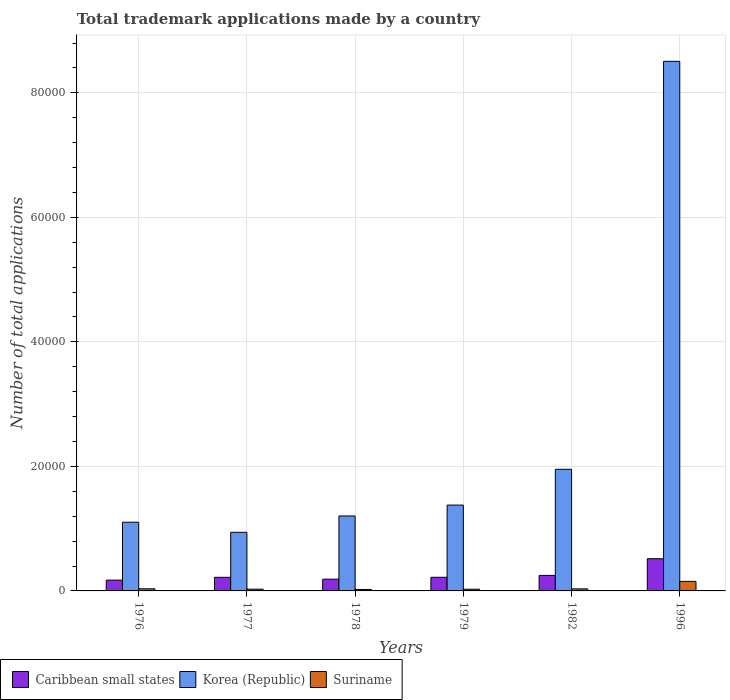How many different coloured bars are there?
Offer a terse response. 3. What is the label of the 4th group of bars from the left?
Your answer should be compact. 1979. What is the number of applications made by in Caribbean small states in 1976?
Your answer should be compact. 1735. Across all years, what is the maximum number of applications made by in Korea (Republic)?
Provide a succinct answer. 8.51e+04. Across all years, what is the minimum number of applications made by in Suriname?
Your response must be concise. 236. In which year was the number of applications made by in Korea (Republic) minimum?
Offer a terse response. 1977. What is the total number of applications made by in Caribbean small states in the graph?
Provide a succinct answer. 1.57e+04. What is the difference between the number of applications made by in Korea (Republic) in 1976 and that in 1982?
Offer a terse response. -8500. What is the difference between the number of applications made by in Korea (Republic) in 1982 and the number of applications made by in Caribbean small states in 1978?
Give a very brief answer. 1.77e+04. What is the average number of applications made by in Caribbean small states per year?
Provide a short and direct response. 2610.17. In the year 1978, what is the difference between the number of applications made by in Suriname and number of applications made by in Korea (Republic)?
Your answer should be very brief. -1.18e+04. What is the ratio of the number of applications made by in Caribbean small states in 1976 to that in 1979?
Provide a succinct answer. 0.79. Is the number of applications made by in Suriname in 1977 less than that in 1978?
Provide a succinct answer. No. What is the difference between the highest and the second highest number of applications made by in Caribbean small states?
Your answer should be compact. 2679. What is the difference between the highest and the lowest number of applications made by in Suriname?
Offer a terse response. 1295. In how many years, is the number of applications made by in Caribbean small states greater than the average number of applications made by in Caribbean small states taken over all years?
Provide a succinct answer. 1. What does the 2nd bar from the left in 1978 represents?
Offer a very short reply. Korea (Republic). What does the 3rd bar from the right in 1996 represents?
Keep it short and to the point. Caribbean small states. Is it the case that in every year, the sum of the number of applications made by in Korea (Republic) and number of applications made by in Suriname is greater than the number of applications made by in Caribbean small states?
Provide a short and direct response. Yes. How many bars are there?
Provide a short and direct response. 18. Are the values on the major ticks of Y-axis written in scientific E-notation?
Offer a terse response. No. Does the graph contain any zero values?
Make the answer very short. No. Does the graph contain grids?
Offer a very short reply. Yes. How many legend labels are there?
Offer a terse response. 3. What is the title of the graph?
Give a very brief answer. Total trademark applications made by a country. Does "Uruguay" appear as one of the legend labels in the graph?
Offer a terse response. No. What is the label or title of the X-axis?
Make the answer very short. Years. What is the label or title of the Y-axis?
Your answer should be very brief. Number of total applications. What is the Number of total applications in Caribbean small states in 1976?
Your response must be concise. 1735. What is the Number of total applications in Korea (Republic) in 1976?
Offer a very short reply. 1.10e+04. What is the Number of total applications of Suriname in 1976?
Your answer should be compact. 343. What is the Number of total applications in Caribbean small states in 1977?
Provide a short and direct response. 2185. What is the Number of total applications in Korea (Republic) in 1977?
Make the answer very short. 9415. What is the Number of total applications in Suriname in 1977?
Ensure brevity in your answer.  281. What is the Number of total applications of Caribbean small states in 1978?
Ensure brevity in your answer.  1885. What is the Number of total applications in Korea (Republic) in 1978?
Offer a terse response. 1.20e+04. What is the Number of total applications in Suriname in 1978?
Offer a terse response. 236. What is the Number of total applications of Caribbean small states in 1979?
Your answer should be compact. 2189. What is the Number of total applications in Korea (Republic) in 1979?
Give a very brief answer. 1.38e+04. What is the Number of total applications of Suriname in 1979?
Provide a short and direct response. 271. What is the Number of total applications of Caribbean small states in 1982?
Your answer should be compact. 2494. What is the Number of total applications in Korea (Republic) in 1982?
Your answer should be very brief. 1.95e+04. What is the Number of total applications in Suriname in 1982?
Your answer should be very brief. 331. What is the Number of total applications in Caribbean small states in 1996?
Give a very brief answer. 5173. What is the Number of total applications of Korea (Republic) in 1996?
Your answer should be compact. 8.51e+04. What is the Number of total applications of Suriname in 1996?
Give a very brief answer. 1531. Across all years, what is the maximum Number of total applications of Caribbean small states?
Offer a very short reply. 5173. Across all years, what is the maximum Number of total applications in Korea (Republic)?
Your answer should be very brief. 8.51e+04. Across all years, what is the maximum Number of total applications in Suriname?
Your answer should be very brief. 1531. Across all years, what is the minimum Number of total applications in Caribbean small states?
Give a very brief answer. 1735. Across all years, what is the minimum Number of total applications of Korea (Republic)?
Provide a short and direct response. 9415. Across all years, what is the minimum Number of total applications of Suriname?
Make the answer very short. 236. What is the total Number of total applications in Caribbean small states in the graph?
Your response must be concise. 1.57e+04. What is the total Number of total applications in Korea (Republic) in the graph?
Ensure brevity in your answer.  1.51e+05. What is the total Number of total applications of Suriname in the graph?
Keep it short and to the point. 2993. What is the difference between the Number of total applications of Caribbean small states in 1976 and that in 1977?
Your answer should be very brief. -450. What is the difference between the Number of total applications of Korea (Republic) in 1976 and that in 1977?
Provide a short and direct response. 1622. What is the difference between the Number of total applications of Caribbean small states in 1976 and that in 1978?
Your answer should be very brief. -150. What is the difference between the Number of total applications in Korea (Republic) in 1976 and that in 1978?
Your answer should be very brief. -1003. What is the difference between the Number of total applications in Suriname in 1976 and that in 1978?
Offer a terse response. 107. What is the difference between the Number of total applications of Caribbean small states in 1976 and that in 1979?
Offer a terse response. -454. What is the difference between the Number of total applications of Korea (Republic) in 1976 and that in 1979?
Your answer should be compact. -2752. What is the difference between the Number of total applications in Suriname in 1976 and that in 1979?
Ensure brevity in your answer.  72. What is the difference between the Number of total applications in Caribbean small states in 1976 and that in 1982?
Make the answer very short. -759. What is the difference between the Number of total applications of Korea (Republic) in 1976 and that in 1982?
Your answer should be very brief. -8500. What is the difference between the Number of total applications in Caribbean small states in 1976 and that in 1996?
Offer a very short reply. -3438. What is the difference between the Number of total applications of Korea (Republic) in 1976 and that in 1996?
Make the answer very short. -7.40e+04. What is the difference between the Number of total applications in Suriname in 1976 and that in 1996?
Provide a short and direct response. -1188. What is the difference between the Number of total applications in Caribbean small states in 1977 and that in 1978?
Your response must be concise. 300. What is the difference between the Number of total applications of Korea (Republic) in 1977 and that in 1978?
Offer a very short reply. -2625. What is the difference between the Number of total applications in Suriname in 1977 and that in 1978?
Your answer should be compact. 45. What is the difference between the Number of total applications of Korea (Republic) in 1977 and that in 1979?
Give a very brief answer. -4374. What is the difference between the Number of total applications of Caribbean small states in 1977 and that in 1982?
Make the answer very short. -309. What is the difference between the Number of total applications of Korea (Republic) in 1977 and that in 1982?
Your response must be concise. -1.01e+04. What is the difference between the Number of total applications of Caribbean small states in 1977 and that in 1996?
Give a very brief answer. -2988. What is the difference between the Number of total applications of Korea (Republic) in 1977 and that in 1996?
Give a very brief answer. -7.56e+04. What is the difference between the Number of total applications of Suriname in 1977 and that in 1996?
Your answer should be very brief. -1250. What is the difference between the Number of total applications in Caribbean small states in 1978 and that in 1979?
Keep it short and to the point. -304. What is the difference between the Number of total applications of Korea (Republic) in 1978 and that in 1979?
Keep it short and to the point. -1749. What is the difference between the Number of total applications of Suriname in 1978 and that in 1979?
Make the answer very short. -35. What is the difference between the Number of total applications in Caribbean small states in 1978 and that in 1982?
Your answer should be compact. -609. What is the difference between the Number of total applications in Korea (Republic) in 1978 and that in 1982?
Make the answer very short. -7497. What is the difference between the Number of total applications of Suriname in 1978 and that in 1982?
Your response must be concise. -95. What is the difference between the Number of total applications in Caribbean small states in 1978 and that in 1996?
Your answer should be compact. -3288. What is the difference between the Number of total applications of Korea (Republic) in 1978 and that in 1996?
Your response must be concise. -7.30e+04. What is the difference between the Number of total applications of Suriname in 1978 and that in 1996?
Ensure brevity in your answer.  -1295. What is the difference between the Number of total applications of Caribbean small states in 1979 and that in 1982?
Give a very brief answer. -305. What is the difference between the Number of total applications of Korea (Republic) in 1979 and that in 1982?
Offer a terse response. -5748. What is the difference between the Number of total applications in Suriname in 1979 and that in 1982?
Ensure brevity in your answer.  -60. What is the difference between the Number of total applications in Caribbean small states in 1979 and that in 1996?
Offer a terse response. -2984. What is the difference between the Number of total applications of Korea (Republic) in 1979 and that in 1996?
Ensure brevity in your answer.  -7.13e+04. What is the difference between the Number of total applications in Suriname in 1979 and that in 1996?
Keep it short and to the point. -1260. What is the difference between the Number of total applications in Caribbean small states in 1982 and that in 1996?
Provide a short and direct response. -2679. What is the difference between the Number of total applications in Korea (Republic) in 1982 and that in 1996?
Offer a very short reply. -6.55e+04. What is the difference between the Number of total applications in Suriname in 1982 and that in 1996?
Offer a terse response. -1200. What is the difference between the Number of total applications of Caribbean small states in 1976 and the Number of total applications of Korea (Republic) in 1977?
Ensure brevity in your answer.  -7680. What is the difference between the Number of total applications of Caribbean small states in 1976 and the Number of total applications of Suriname in 1977?
Give a very brief answer. 1454. What is the difference between the Number of total applications in Korea (Republic) in 1976 and the Number of total applications in Suriname in 1977?
Your answer should be compact. 1.08e+04. What is the difference between the Number of total applications of Caribbean small states in 1976 and the Number of total applications of Korea (Republic) in 1978?
Keep it short and to the point. -1.03e+04. What is the difference between the Number of total applications in Caribbean small states in 1976 and the Number of total applications in Suriname in 1978?
Your answer should be very brief. 1499. What is the difference between the Number of total applications in Korea (Republic) in 1976 and the Number of total applications in Suriname in 1978?
Ensure brevity in your answer.  1.08e+04. What is the difference between the Number of total applications of Caribbean small states in 1976 and the Number of total applications of Korea (Republic) in 1979?
Offer a terse response. -1.21e+04. What is the difference between the Number of total applications in Caribbean small states in 1976 and the Number of total applications in Suriname in 1979?
Offer a terse response. 1464. What is the difference between the Number of total applications in Korea (Republic) in 1976 and the Number of total applications in Suriname in 1979?
Offer a terse response. 1.08e+04. What is the difference between the Number of total applications in Caribbean small states in 1976 and the Number of total applications in Korea (Republic) in 1982?
Your response must be concise. -1.78e+04. What is the difference between the Number of total applications of Caribbean small states in 1976 and the Number of total applications of Suriname in 1982?
Your answer should be compact. 1404. What is the difference between the Number of total applications of Korea (Republic) in 1976 and the Number of total applications of Suriname in 1982?
Your answer should be compact. 1.07e+04. What is the difference between the Number of total applications of Caribbean small states in 1976 and the Number of total applications of Korea (Republic) in 1996?
Your answer should be very brief. -8.33e+04. What is the difference between the Number of total applications in Caribbean small states in 1976 and the Number of total applications in Suriname in 1996?
Offer a very short reply. 204. What is the difference between the Number of total applications in Korea (Republic) in 1976 and the Number of total applications in Suriname in 1996?
Your response must be concise. 9506. What is the difference between the Number of total applications in Caribbean small states in 1977 and the Number of total applications in Korea (Republic) in 1978?
Offer a terse response. -9855. What is the difference between the Number of total applications of Caribbean small states in 1977 and the Number of total applications of Suriname in 1978?
Make the answer very short. 1949. What is the difference between the Number of total applications in Korea (Republic) in 1977 and the Number of total applications in Suriname in 1978?
Offer a very short reply. 9179. What is the difference between the Number of total applications of Caribbean small states in 1977 and the Number of total applications of Korea (Republic) in 1979?
Offer a very short reply. -1.16e+04. What is the difference between the Number of total applications in Caribbean small states in 1977 and the Number of total applications in Suriname in 1979?
Your answer should be very brief. 1914. What is the difference between the Number of total applications of Korea (Republic) in 1977 and the Number of total applications of Suriname in 1979?
Make the answer very short. 9144. What is the difference between the Number of total applications of Caribbean small states in 1977 and the Number of total applications of Korea (Republic) in 1982?
Offer a very short reply. -1.74e+04. What is the difference between the Number of total applications in Caribbean small states in 1977 and the Number of total applications in Suriname in 1982?
Keep it short and to the point. 1854. What is the difference between the Number of total applications of Korea (Republic) in 1977 and the Number of total applications of Suriname in 1982?
Make the answer very short. 9084. What is the difference between the Number of total applications of Caribbean small states in 1977 and the Number of total applications of Korea (Republic) in 1996?
Keep it short and to the point. -8.29e+04. What is the difference between the Number of total applications of Caribbean small states in 1977 and the Number of total applications of Suriname in 1996?
Your answer should be very brief. 654. What is the difference between the Number of total applications in Korea (Republic) in 1977 and the Number of total applications in Suriname in 1996?
Your answer should be very brief. 7884. What is the difference between the Number of total applications of Caribbean small states in 1978 and the Number of total applications of Korea (Republic) in 1979?
Your answer should be very brief. -1.19e+04. What is the difference between the Number of total applications in Caribbean small states in 1978 and the Number of total applications in Suriname in 1979?
Offer a terse response. 1614. What is the difference between the Number of total applications in Korea (Republic) in 1978 and the Number of total applications in Suriname in 1979?
Provide a succinct answer. 1.18e+04. What is the difference between the Number of total applications in Caribbean small states in 1978 and the Number of total applications in Korea (Republic) in 1982?
Your answer should be very brief. -1.77e+04. What is the difference between the Number of total applications in Caribbean small states in 1978 and the Number of total applications in Suriname in 1982?
Provide a short and direct response. 1554. What is the difference between the Number of total applications in Korea (Republic) in 1978 and the Number of total applications in Suriname in 1982?
Offer a terse response. 1.17e+04. What is the difference between the Number of total applications in Caribbean small states in 1978 and the Number of total applications in Korea (Republic) in 1996?
Your answer should be very brief. -8.32e+04. What is the difference between the Number of total applications of Caribbean small states in 1978 and the Number of total applications of Suriname in 1996?
Provide a succinct answer. 354. What is the difference between the Number of total applications in Korea (Republic) in 1978 and the Number of total applications in Suriname in 1996?
Keep it short and to the point. 1.05e+04. What is the difference between the Number of total applications of Caribbean small states in 1979 and the Number of total applications of Korea (Republic) in 1982?
Your response must be concise. -1.73e+04. What is the difference between the Number of total applications of Caribbean small states in 1979 and the Number of total applications of Suriname in 1982?
Provide a succinct answer. 1858. What is the difference between the Number of total applications in Korea (Republic) in 1979 and the Number of total applications in Suriname in 1982?
Provide a short and direct response. 1.35e+04. What is the difference between the Number of total applications in Caribbean small states in 1979 and the Number of total applications in Korea (Republic) in 1996?
Your answer should be compact. -8.29e+04. What is the difference between the Number of total applications of Caribbean small states in 1979 and the Number of total applications of Suriname in 1996?
Your answer should be compact. 658. What is the difference between the Number of total applications in Korea (Republic) in 1979 and the Number of total applications in Suriname in 1996?
Ensure brevity in your answer.  1.23e+04. What is the difference between the Number of total applications of Caribbean small states in 1982 and the Number of total applications of Korea (Republic) in 1996?
Provide a succinct answer. -8.26e+04. What is the difference between the Number of total applications in Caribbean small states in 1982 and the Number of total applications in Suriname in 1996?
Provide a succinct answer. 963. What is the difference between the Number of total applications in Korea (Republic) in 1982 and the Number of total applications in Suriname in 1996?
Your answer should be compact. 1.80e+04. What is the average Number of total applications in Caribbean small states per year?
Offer a very short reply. 2610.17. What is the average Number of total applications of Korea (Republic) per year?
Keep it short and to the point. 2.51e+04. What is the average Number of total applications of Suriname per year?
Your response must be concise. 498.83. In the year 1976, what is the difference between the Number of total applications in Caribbean small states and Number of total applications in Korea (Republic)?
Offer a terse response. -9302. In the year 1976, what is the difference between the Number of total applications in Caribbean small states and Number of total applications in Suriname?
Your response must be concise. 1392. In the year 1976, what is the difference between the Number of total applications in Korea (Republic) and Number of total applications in Suriname?
Offer a very short reply. 1.07e+04. In the year 1977, what is the difference between the Number of total applications in Caribbean small states and Number of total applications in Korea (Republic)?
Provide a short and direct response. -7230. In the year 1977, what is the difference between the Number of total applications of Caribbean small states and Number of total applications of Suriname?
Ensure brevity in your answer.  1904. In the year 1977, what is the difference between the Number of total applications in Korea (Republic) and Number of total applications in Suriname?
Your answer should be very brief. 9134. In the year 1978, what is the difference between the Number of total applications of Caribbean small states and Number of total applications of Korea (Republic)?
Your answer should be very brief. -1.02e+04. In the year 1978, what is the difference between the Number of total applications in Caribbean small states and Number of total applications in Suriname?
Give a very brief answer. 1649. In the year 1978, what is the difference between the Number of total applications of Korea (Republic) and Number of total applications of Suriname?
Ensure brevity in your answer.  1.18e+04. In the year 1979, what is the difference between the Number of total applications of Caribbean small states and Number of total applications of Korea (Republic)?
Provide a short and direct response. -1.16e+04. In the year 1979, what is the difference between the Number of total applications in Caribbean small states and Number of total applications in Suriname?
Make the answer very short. 1918. In the year 1979, what is the difference between the Number of total applications in Korea (Republic) and Number of total applications in Suriname?
Offer a terse response. 1.35e+04. In the year 1982, what is the difference between the Number of total applications of Caribbean small states and Number of total applications of Korea (Republic)?
Keep it short and to the point. -1.70e+04. In the year 1982, what is the difference between the Number of total applications in Caribbean small states and Number of total applications in Suriname?
Provide a short and direct response. 2163. In the year 1982, what is the difference between the Number of total applications of Korea (Republic) and Number of total applications of Suriname?
Your response must be concise. 1.92e+04. In the year 1996, what is the difference between the Number of total applications of Caribbean small states and Number of total applications of Korea (Republic)?
Your response must be concise. -7.99e+04. In the year 1996, what is the difference between the Number of total applications of Caribbean small states and Number of total applications of Suriname?
Ensure brevity in your answer.  3642. In the year 1996, what is the difference between the Number of total applications in Korea (Republic) and Number of total applications in Suriname?
Give a very brief answer. 8.35e+04. What is the ratio of the Number of total applications in Caribbean small states in 1976 to that in 1977?
Make the answer very short. 0.79. What is the ratio of the Number of total applications in Korea (Republic) in 1976 to that in 1977?
Ensure brevity in your answer.  1.17. What is the ratio of the Number of total applications of Suriname in 1976 to that in 1977?
Ensure brevity in your answer.  1.22. What is the ratio of the Number of total applications of Caribbean small states in 1976 to that in 1978?
Your response must be concise. 0.92. What is the ratio of the Number of total applications in Korea (Republic) in 1976 to that in 1978?
Your answer should be compact. 0.92. What is the ratio of the Number of total applications of Suriname in 1976 to that in 1978?
Your response must be concise. 1.45. What is the ratio of the Number of total applications in Caribbean small states in 1976 to that in 1979?
Your answer should be very brief. 0.79. What is the ratio of the Number of total applications of Korea (Republic) in 1976 to that in 1979?
Provide a succinct answer. 0.8. What is the ratio of the Number of total applications of Suriname in 1976 to that in 1979?
Provide a succinct answer. 1.27. What is the ratio of the Number of total applications of Caribbean small states in 1976 to that in 1982?
Make the answer very short. 0.7. What is the ratio of the Number of total applications in Korea (Republic) in 1976 to that in 1982?
Your answer should be compact. 0.56. What is the ratio of the Number of total applications in Suriname in 1976 to that in 1982?
Provide a short and direct response. 1.04. What is the ratio of the Number of total applications in Caribbean small states in 1976 to that in 1996?
Your answer should be compact. 0.34. What is the ratio of the Number of total applications of Korea (Republic) in 1976 to that in 1996?
Give a very brief answer. 0.13. What is the ratio of the Number of total applications of Suriname in 1976 to that in 1996?
Offer a terse response. 0.22. What is the ratio of the Number of total applications in Caribbean small states in 1977 to that in 1978?
Keep it short and to the point. 1.16. What is the ratio of the Number of total applications of Korea (Republic) in 1977 to that in 1978?
Provide a short and direct response. 0.78. What is the ratio of the Number of total applications in Suriname in 1977 to that in 1978?
Your answer should be compact. 1.19. What is the ratio of the Number of total applications of Caribbean small states in 1977 to that in 1979?
Ensure brevity in your answer.  1. What is the ratio of the Number of total applications in Korea (Republic) in 1977 to that in 1979?
Ensure brevity in your answer.  0.68. What is the ratio of the Number of total applications in Suriname in 1977 to that in 1979?
Provide a short and direct response. 1.04. What is the ratio of the Number of total applications in Caribbean small states in 1977 to that in 1982?
Your answer should be compact. 0.88. What is the ratio of the Number of total applications in Korea (Republic) in 1977 to that in 1982?
Your answer should be very brief. 0.48. What is the ratio of the Number of total applications in Suriname in 1977 to that in 1982?
Ensure brevity in your answer.  0.85. What is the ratio of the Number of total applications in Caribbean small states in 1977 to that in 1996?
Provide a succinct answer. 0.42. What is the ratio of the Number of total applications of Korea (Republic) in 1977 to that in 1996?
Give a very brief answer. 0.11. What is the ratio of the Number of total applications in Suriname in 1977 to that in 1996?
Your answer should be very brief. 0.18. What is the ratio of the Number of total applications of Caribbean small states in 1978 to that in 1979?
Provide a short and direct response. 0.86. What is the ratio of the Number of total applications in Korea (Republic) in 1978 to that in 1979?
Give a very brief answer. 0.87. What is the ratio of the Number of total applications of Suriname in 1978 to that in 1979?
Provide a succinct answer. 0.87. What is the ratio of the Number of total applications in Caribbean small states in 1978 to that in 1982?
Your answer should be compact. 0.76. What is the ratio of the Number of total applications of Korea (Republic) in 1978 to that in 1982?
Provide a short and direct response. 0.62. What is the ratio of the Number of total applications of Suriname in 1978 to that in 1982?
Offer a very short reply. 0.71. What is the ratio of the Number of total applications of Caribbean small states in 1978 to that in 1996?
Your answer should be compact. 0.36. What is the ratio of the Number of total applications in Korea (Republic) in 1978 to that in 1996?
Keep it short and to the point. 0.14. What is the ratio of the Number of total applications in Suriname in 1978 to that in 1996?
Provide a succinct answer. 0.15. What is the ratio of the Number of total applications in Caribbean small states in 1979 to that in 1982?
Offer a terse response. 0.88. What is the ratio of the Number of total applications in Korea (Republic) in 1979 to that in 1982?
Ensure brevity in your answer.  0.71. What is the ratio of the Number of total applications of Suriname in 1979 to that in 1982?
Ensure brevity in your answer.  0.82. What is the ratio of the Number of total applications of Caribbean small states in 1979 to that in 1996?
Ensure brevity in your answer.  0.42. What is the ratio of the Number of total applications in Korea (Republic) in 1979 to that in 1996?
Your response must be concise. 0.16. What is the ratio of the Number of total applications of Suriname in 1979 to that in 1996?
Your response must be concise. 0.18. What is the ratio of the Number of total applications in Caribbean small states in 1982 to that in 1996?
Your answer should be very brief. 0.48. What is the ratio of the Number of total applications of Korea (Republic) in 1982 to that in 1996?
Offer a terse response. 0.23. What is the ratio of the Number of total applications in Suriname in 1982 to that in 1996?
Provide a short and direct response. 0.22. What is the difference between the highest and the second highest Number of total applications of Caribbean small states?
Make the answer very short. 2679. What is the difference between the highest and the second highest Number of total applications in Korea (Republic)?
Your answer should be compact. 6.55e+04. What is the difference between the highest and the second highest Number of total applications in Suriname?
Ensure brevity in your answer.  1188. What is the difference between the highest and the lowest Number of total applications of Caribbean small states?
Offer a very short reply. 3438. What is the difference between the highest and the lowest Number of total applications in Korea (Republic)?
Provide a short and direct response. 7.56e+04. What is the difference between the highest and the lowest Number of total applications in Suriname?
Make the answer very short. 1295. 